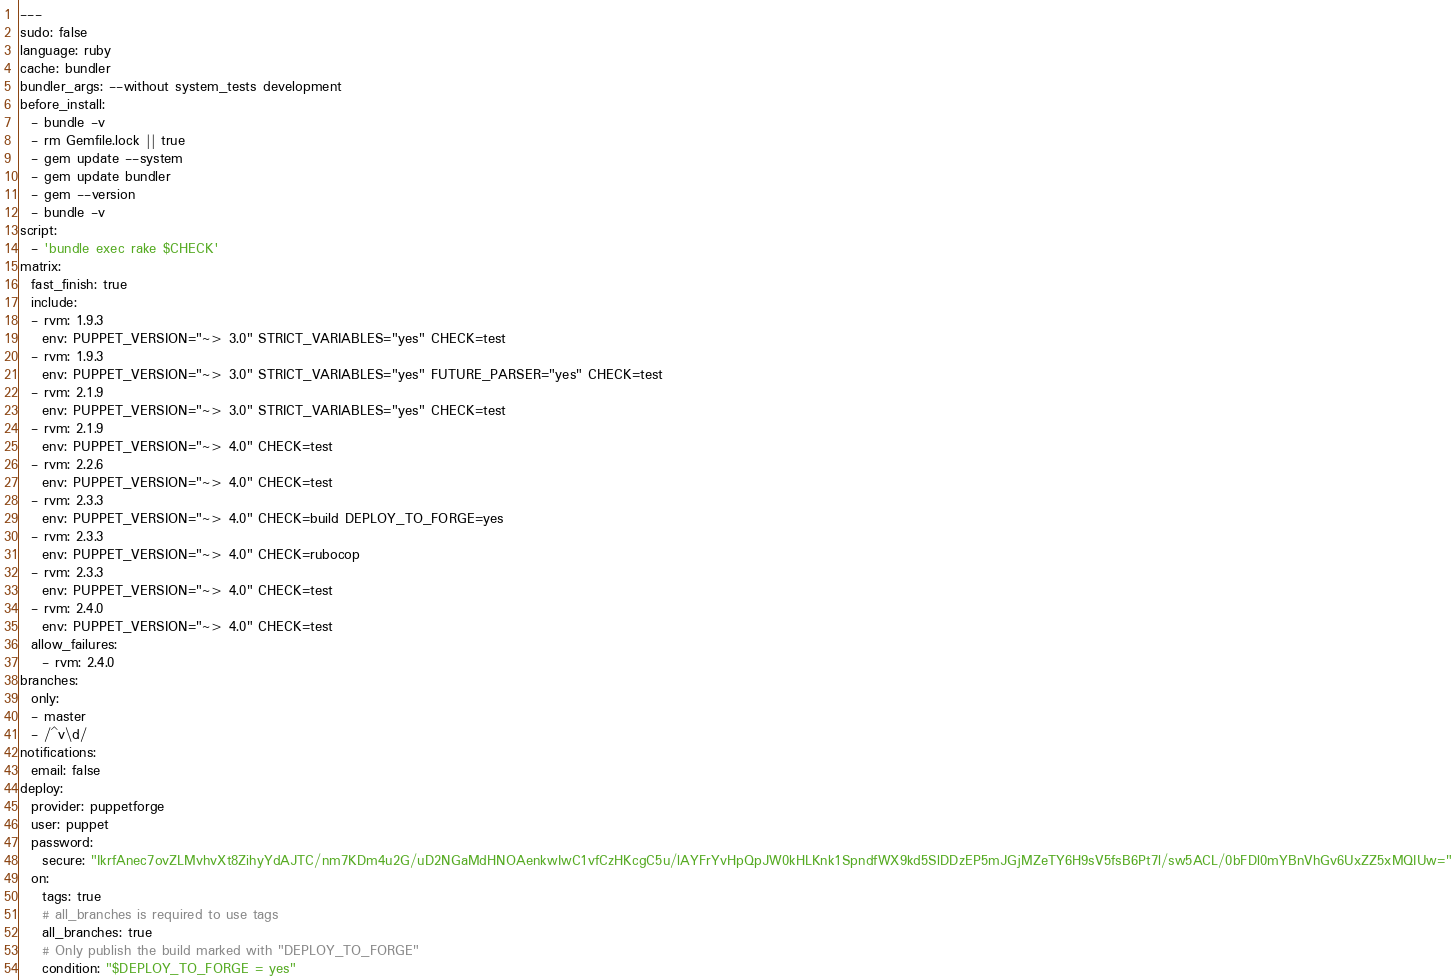<code> <loc_0><loc_0><loc_500><loc_500><_YAML_>---
sudo: false
language: ruby
cache: bundler
bundler_args: --without system_tests development
before_install:
  - bundle -v
  - rm Gemfile.lock || true
  - gem update --system
  - gem update bundler
  - gem --version
  - bundle -v
script:
  - 'bundle exec rake $CHECK'
matrix:
  fast_finish: true
  include:
  - rvm: 1.9.3
    env: PUPPET_VERSION="~> 3.0" STRICT_VARIABLES="yes" CHECK=test
  - rvm: 1.9.3
    env: PUPPET_VERSION="~> 3.0" STRICT_VARIABLES="yes" FUTURE_PARSER="yes" CHECK=test
  - rvm: 2.1.9
    env: PUPPET_VERSION="~> 3.0" STRICT_VARIABLES="yes" CHECK=test
  - rvm: 2.1.9
    env: PUPPET_VERSION="~> 4.0" CHECK=test
  - rvm: 2.2.6
    env: PUPPET_VERSION="~> 4.0" CHECK=test
  - rvm: 2.3.3
    env: PUPPET_VERSION="~> 4.0" CHECK=build DEPLOY_TO_FORGE=yes
  - rvm: 2.3.3
    env: PUPPET_VERSION="~> 4.0" CHECK=rubocop
  - rvm: 2.3.3
    env: PUPPET_VERSION="~> 4.0" CHECK=test
  - rvm: 2.4.0
    env: PUPPET_VERSION="~> 4.0" CHECK=test
  allow_failures:
    - rvm: 2.4.0
branches:
  only:
  - master
  - /^v\d/
notifications:
  email: false
deploy:
  provider: puppetforge
  user: puppet
  password:
    secure: "IkrfAnec7ovZLMvhvXt8ZihyYdAJTC/nm7KDm4u2G/uD2NGaMdHNOAenkwIwC1vfCzHKcgC5u/lAYFrYvHpQpJW0kHLKnk1SpndfWX9kd5SlDDzEP5mJGjMZeTY6H9sV5fsB6Pt7l/sw5ACL/0bFDl0mYBnVhGv6UxZZ5xMQIUw="
  on:
    tags: true
    # all_branches is required to use tags
    all_branches: true
    # Only publish the build marked with "DEPLOY_TO_FORGE"
    condition: "$DEPLOY_TO_FORGE = yes"
</code> 